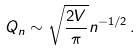Convert formula to latex. <formula><loc_0><loc_0><loc_500><loc_500>Q _ { n } \sim \sqrt { \frac { 2 V } { \pi } } n ^ { - 1 / 2 } \, .</formula> 